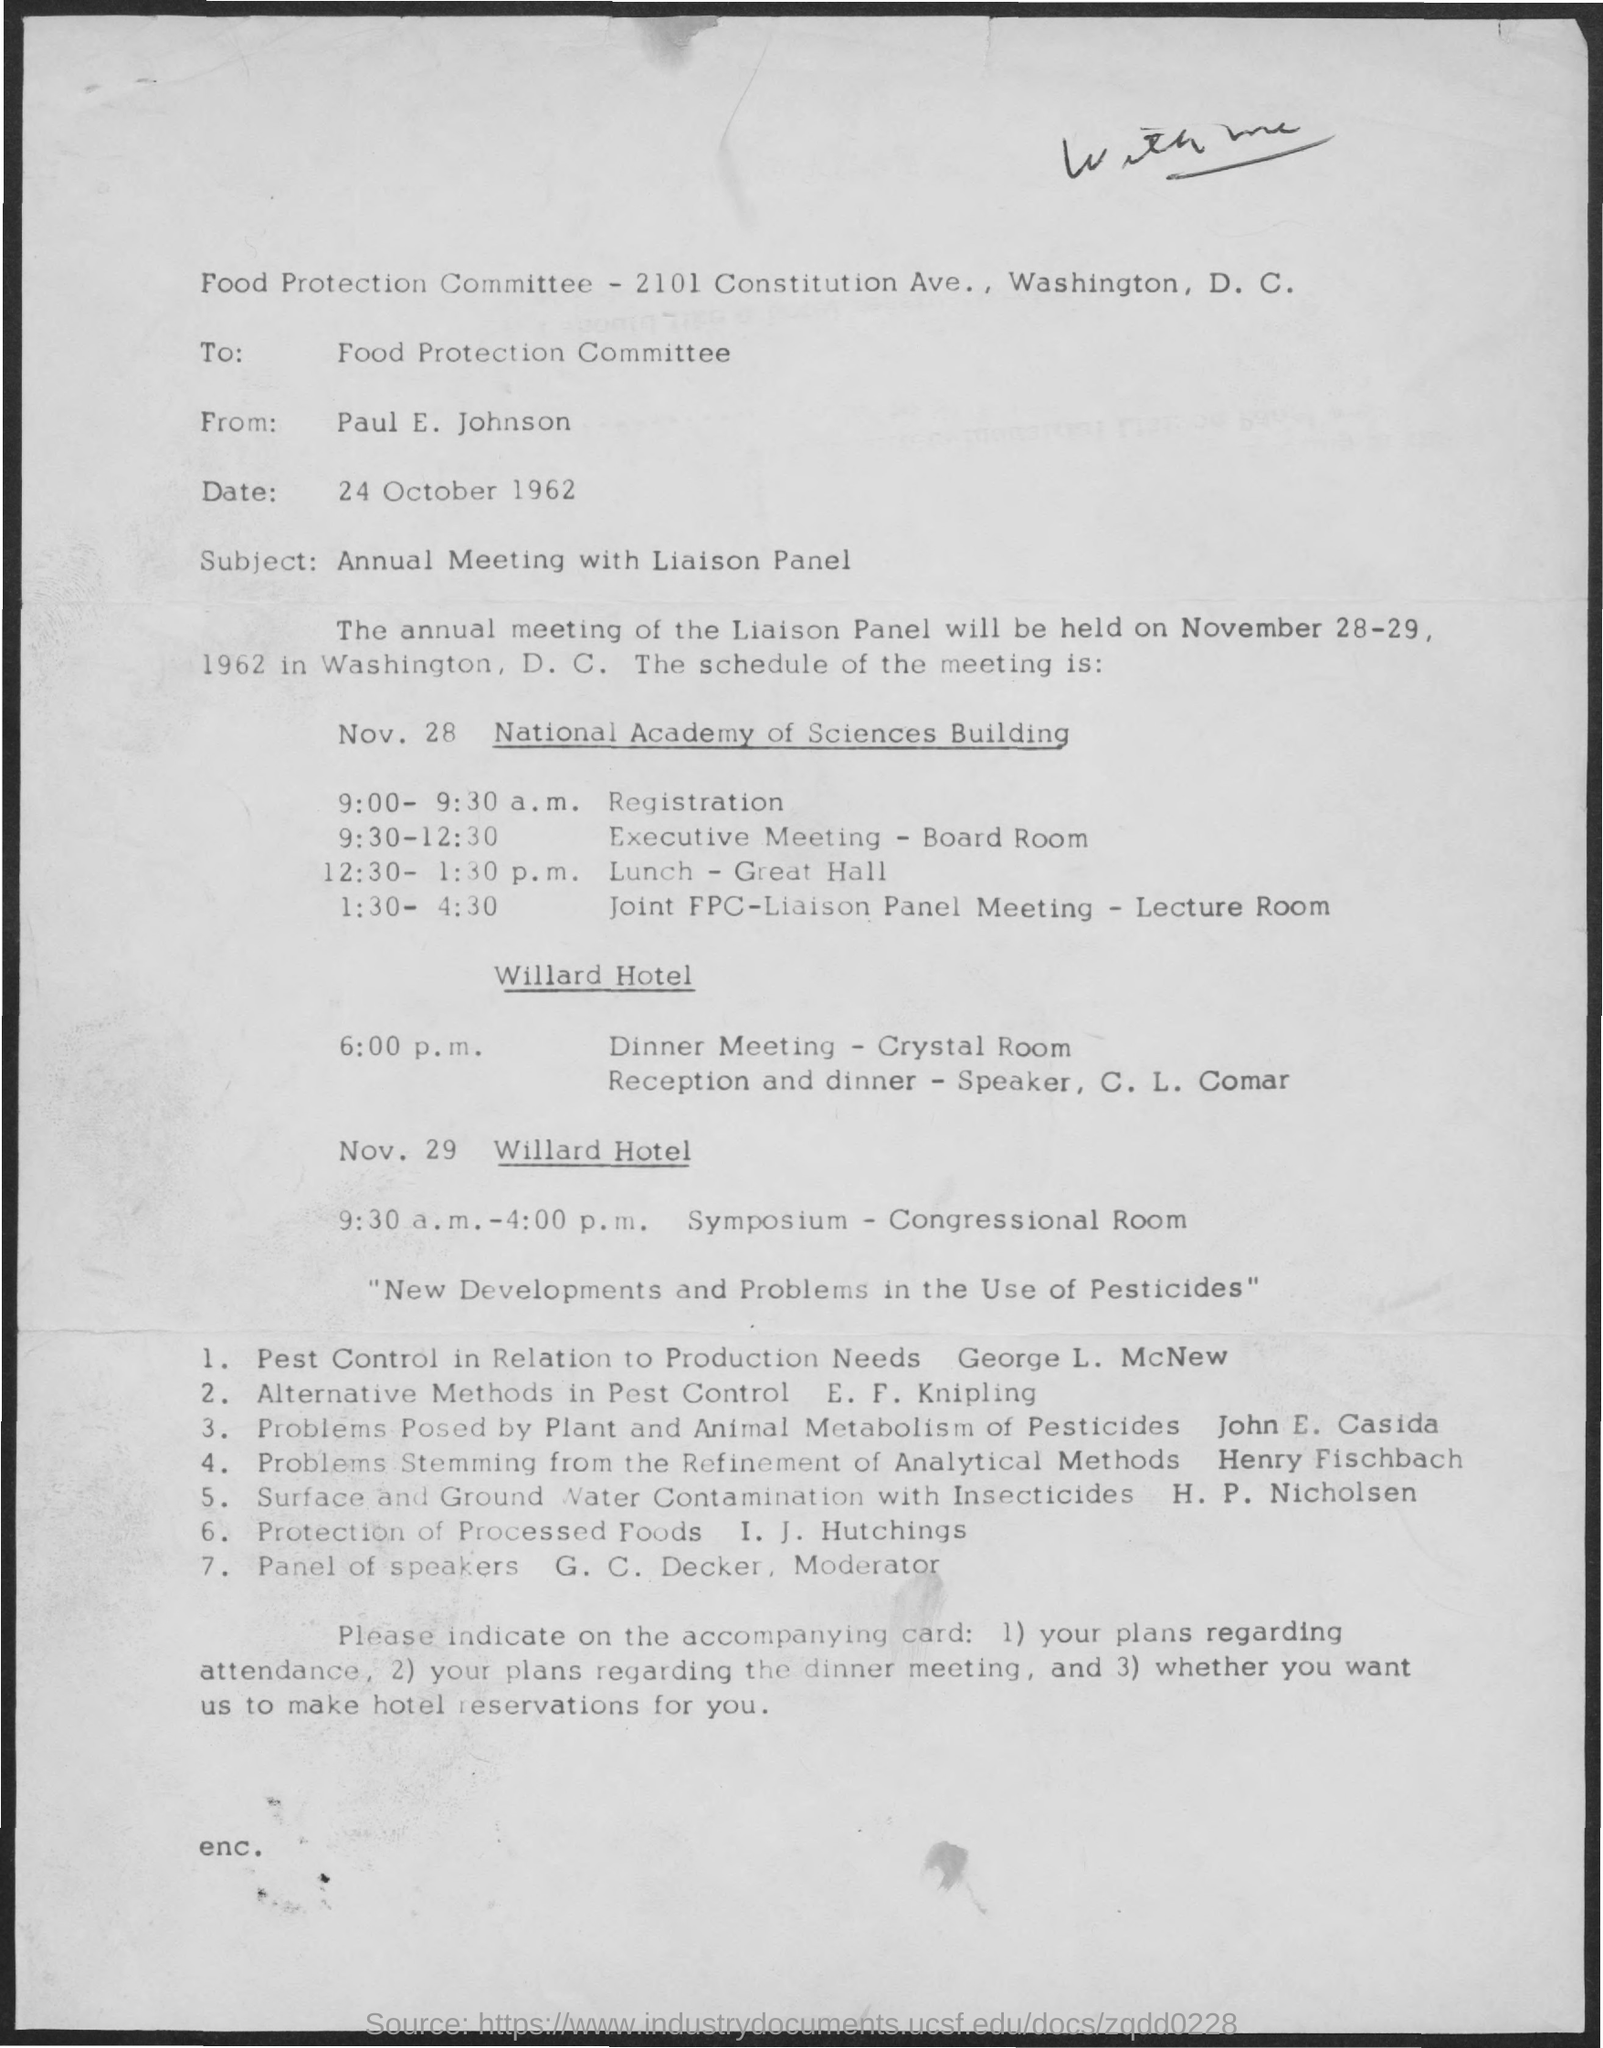Point out several critical features in this image. The address for the Food Protection committee is 2101 Constitution Ave., Washington, D.C. The date is October 24, 1962. This letter is addressed to the Food Protection committee. The November 29 symposium will be held from 9:30 a.m. to 4:00 p.m. The registration will take place between 9:00 and 9:30 a.m. 